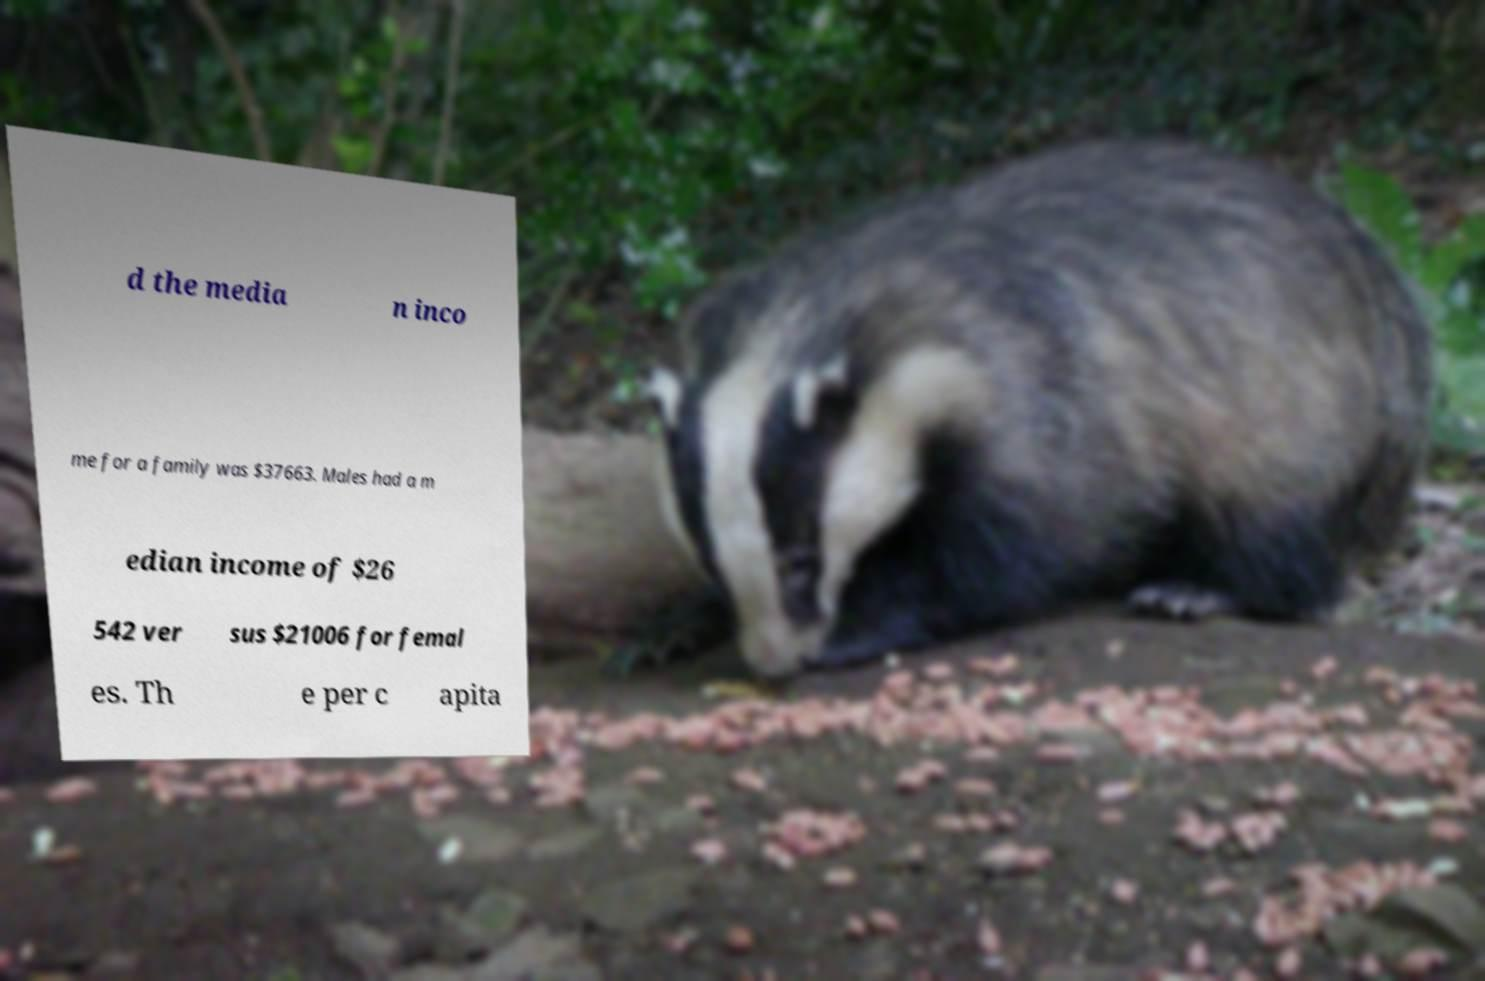There's text embedded in this image that I need extracted. Can you transcribe it verbatim? d the media n inco me for a family was $37663. Males had a m edian income of $26 542 ver sus $21006 for femal es. Th e per c apita 